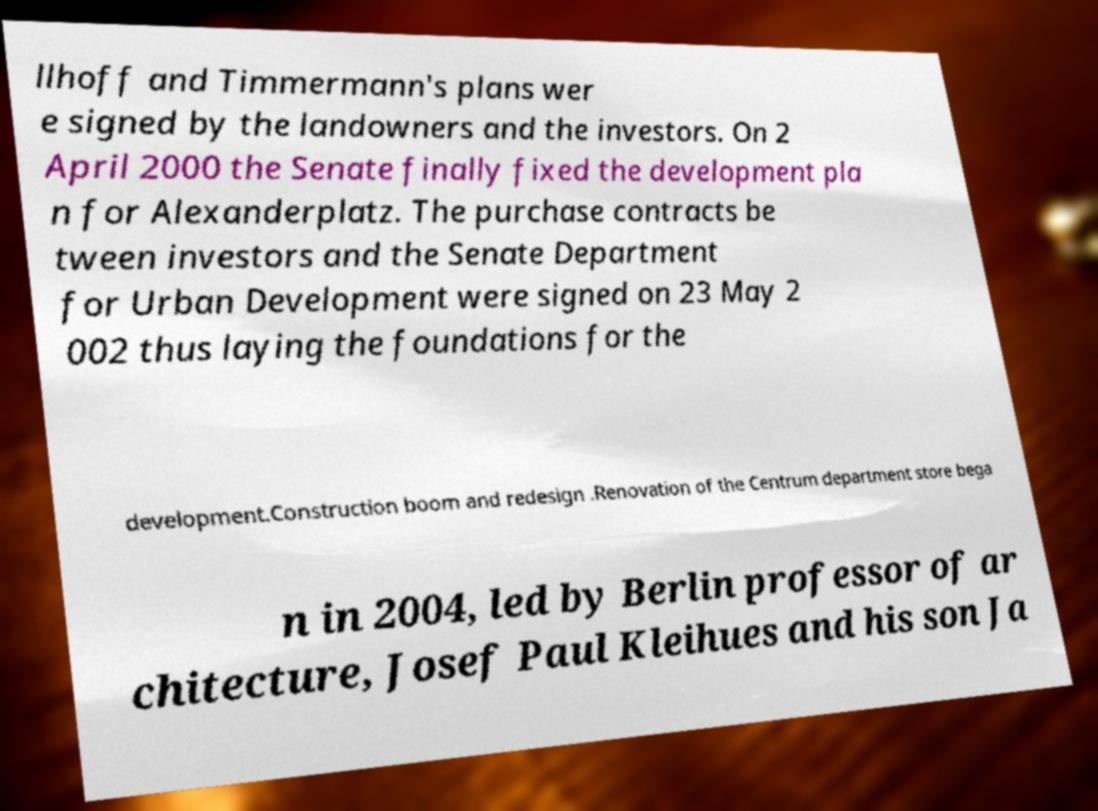Please read and relay the text visible in this image. What does it say? llhoff and Timmermann's plans wer e signed by the landowners and the investors. On 2 April 2000 the Senate finally fixed the development pla n for Alexanderplatz. The purchase contracts be tween investors and the Senate Department for Urban Development were signed on 23 May 2 002 thus laying the foundations for the development.Construction boom and redesign .Renovation of the Centrum department store bega n in 2004, led by Berlin professor of ar chitecture, Josef Paul Kleihues and his son Ja 